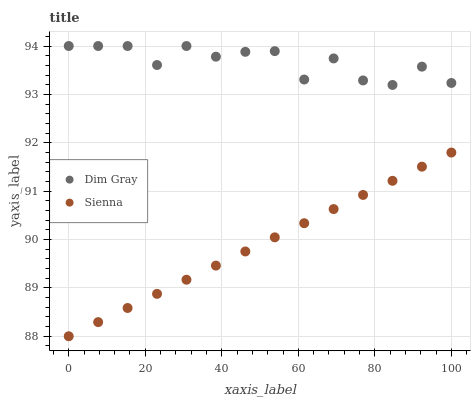Does Sienna have the minimum area under the curve?
Answer yes or no. Yes. Does Dim Gray have the maximum area under the curve?
Answer yes or no. Yes. Does Dim Gray have the minimum area under the curve?
Answer yes or no. No. Is Sienna the smoothest?
Answer yes or no. Yes. Is Dim Gray the roughest?
Answer yes or no. Yes. Is Dim Gray the smoothest?
Answer yes or no. No. Does Sienna have the lowest value?
Answer yes or no. Yes. Does Dim Gray have the lowest value?
Answer yes or no. No. Does Dim Gray have the highest value?
Answer yes or no. Yes. Is Sienna less than Dim Gray?
Answer yes or no. Yes. Is Dim Gray greater than Sienna?
Answer yes or no. Yes. Does Sienna intersect Dim Gray?
Answer yes or no. No. 